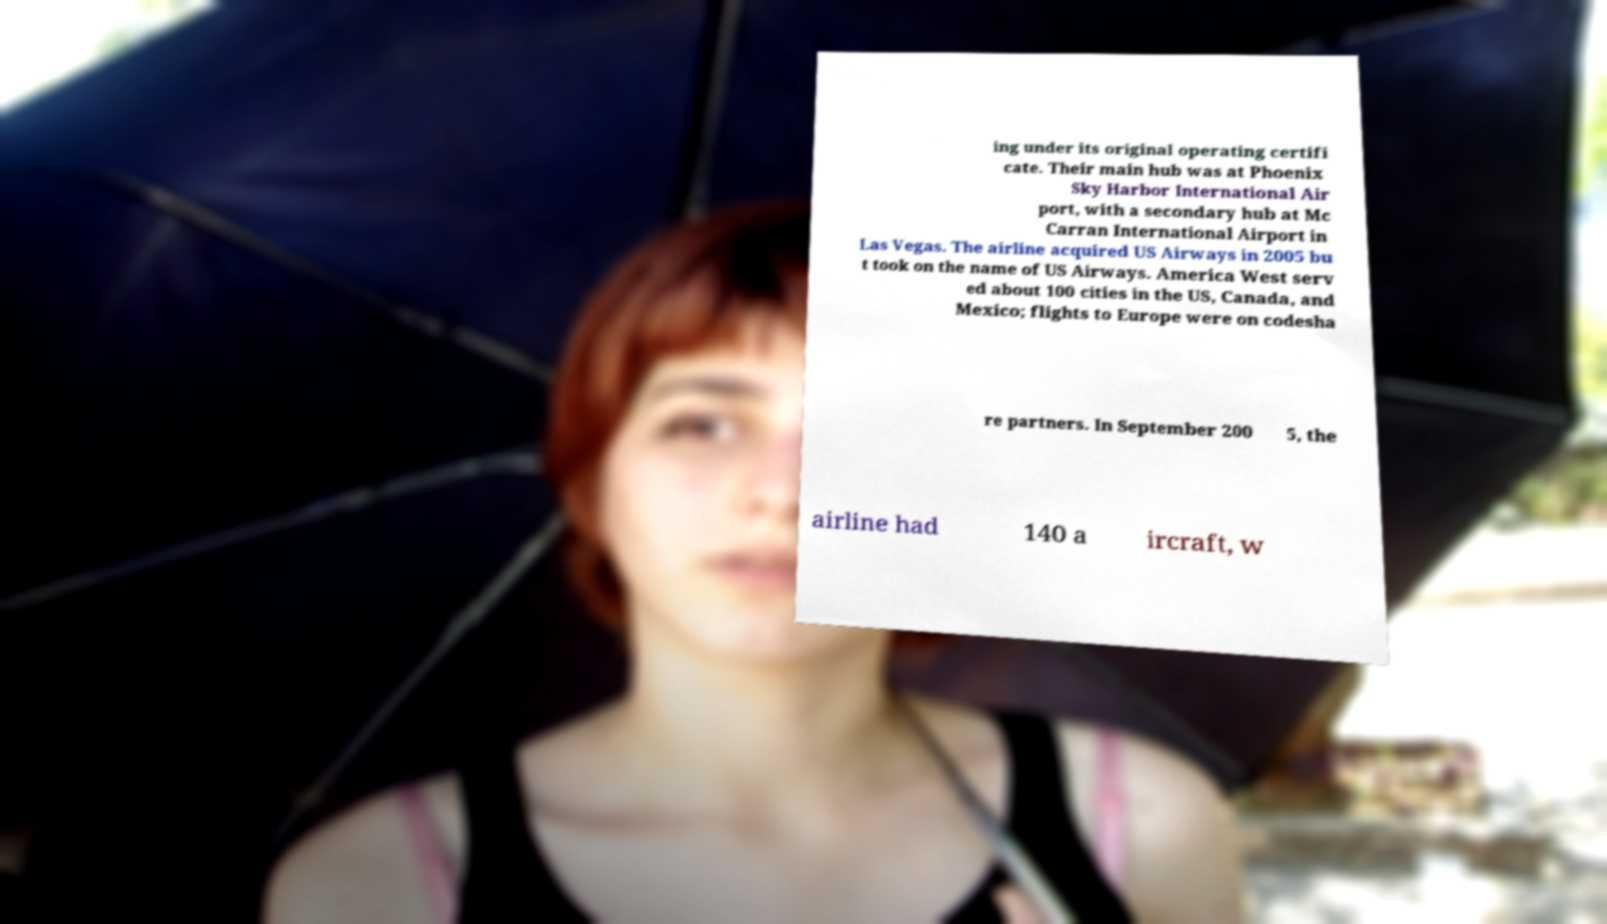Could you extract and type out the text from this image? ing under its original operating certifi cate. Their main hub was at Phoenix Sky Harbor International Air port, with a secondary hub at Mc Carran International Airport in Las Vegas. The airline acquired US Airways in 2005 bu t took on the name of US Airways. America West serv ed about 100 cities in the US, Canada, and Mexico; flights to Europe were on codesha re partners. In September 200 5, the airline had 140 a ircraft, w 